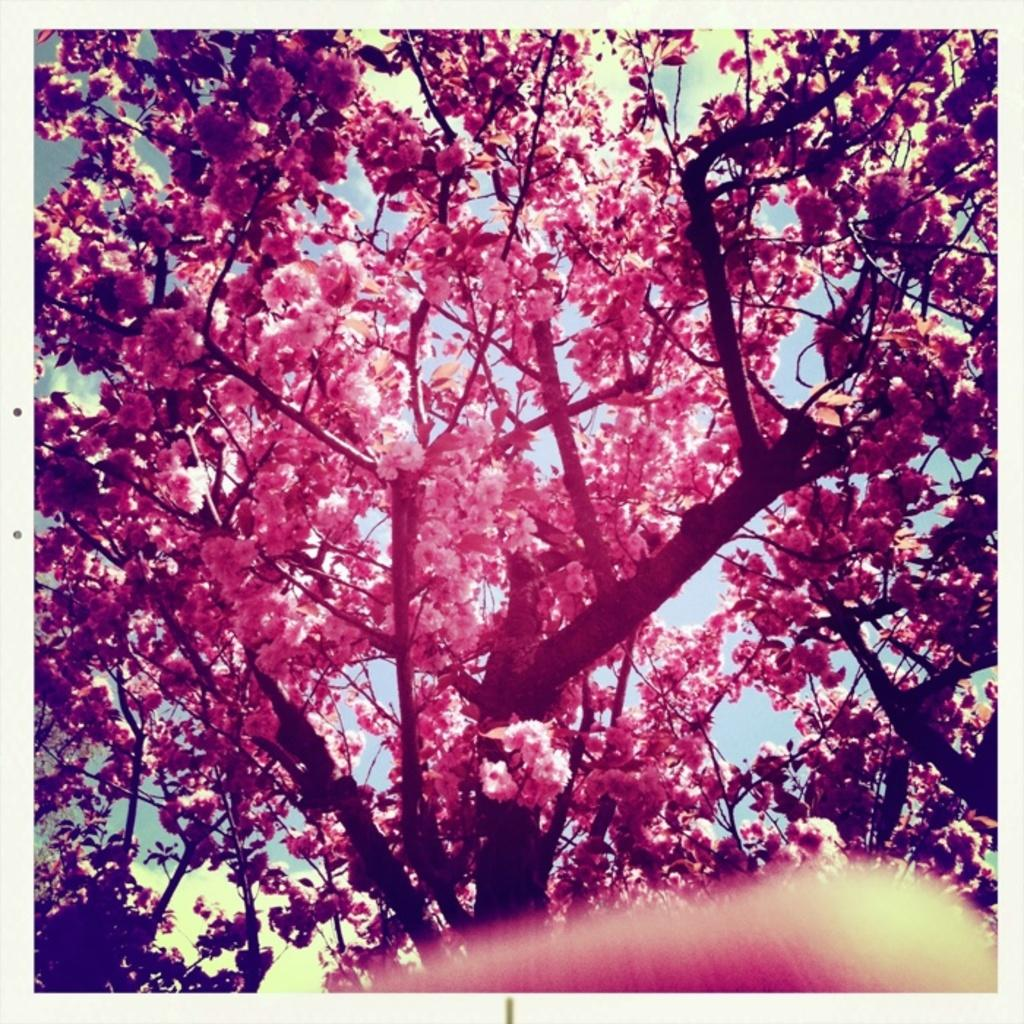What type of vegetation is present in the image? There are trees with flowers in the image. What can be found at the bottom of the image? There is an object at the bottom of the image. What is visible in the sky in the background of the image? There are clouds visible in the sky in the background of the image. How does the muscle in the image affect the quiver of the trees? There is no muscle or quiver present in the image; it features trees with flowers and an unspecified object at the bottom. 